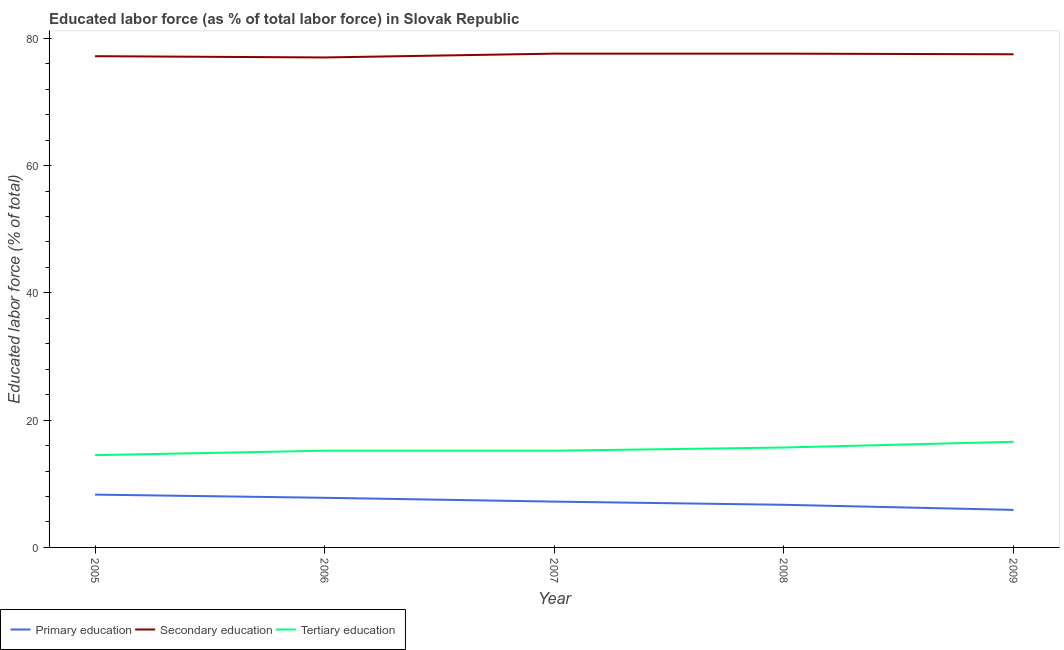How many different coloured lines are there?
Your response must be concise. 3. Is the number of lines equal to the number of legend labels?
Provide a succinct answer. Yes. What is the percentage of labor force who received primary education in 2008?
Ensure brevity in your answer.  6.7. Across all years, what is the maximum percentage of labor force who received secondary education?
Give a very brief answer. 77.6. Across all years, what is the minimum percentage of labor force who received secondary education?
Provide a short and direct response. 77. In which year was the percentage of labor force who received tertiary education maximum?
Give a very brief answer. 2009. In which year was the percentage of labor force who received tertiary education minimum?
Make the answer very short. 2005. What is the total percentage of labor force who received tertiary education in the graph?
Offer a terse response. 77.2. What is the difference between the percentage of labor force who received primary education in 2008 and that in 2009?
Offer a very short reply. 0.8. What is the difference between the percentage of labor force who received primary education in 2007 and the percentage of labor force who received secondary education in 2005?
Give a very brief answer. -70. What is the average percentage of labor force who received secondary education per year?
Ensure brevity in your answer.  77.38. In the year 2007, what is the difference between the percentage of labor force who received secondary education and percentage of labor force who received tertiary education?
Provide a succinct answer. 62.4. What is the ratio of the percentage of labor force who received tertiary education in 2008 to that in 2009?
Offer a terse response. 0.95. Is the percentage of labor force who received tertiary education in 2005 less than that in 2006?
Offer a very short reply. Yes. What is the difference between the highest and the second highest percentage of labor force who received primary education?
Provide a succinct answer. 0.5. What is the difference between the highest and the lowest percentage of labor force who received tertiary education?
Provide a short and direct response. 2.1. Is the sum of the percentage of labor force who received secondary education in 2005 and 2007 greater than the maximum percentage of labor force who received tertiary education across all years?
Your answer should be compact. Yes. Is it the case that in every year, the sum of the percentage of labor force who received primary education and percentage of labor force who received secondary education is greater than the percentage of labor force who received tertiary education?
Provide a short and direct response. Yes. How many lines are there?
Keep it short and to the point. 3. What is the difference between two consecutive major ticks on the Y-axis?
Your response must be concise. 20. Are the values on the major ticks of Y-axis written in scientific E-notation?
Your answer should be compact. No. Does the graph contain any zero values?
Your answer should be very brief. No. Does the graph contain grids?
Keep it short and to the point. No. Where does the legend appear in the graph?
Provide a short and direct response. Bottom left. What is the title of the graph?
Ensure brevity in your answer.  Educated labor force (as % of total labor force) in Slovak Republic. Does "Labor Tax" appear as one of the legend labels in the graph?
Provide a succinct answer. No. What is the label or title of the Y-axis?
Provide a short and direct response. Educated labor force (% of total). What is the Educated labor force (% of total) in Primary education in 2005?
Your answer should be very brief. 8.3. What is the Educated labor force (% of total) in Secondary education in 2005?
Your answer should be very brief. 77.2. What is the Educated labor force (% of total) of Tertiary education in 2005?
Provide a succinct answer. 14.5. What is the Educated labor force (% of total) of Primary education in 2006?
Your answer should be very brief. 7.8. What is the Educated labor force (% of total) in Tertiary education in 2006?
Make the answer very short. 15.2. What is the Educated labor force (% of total) of Primary education in 2007?
Your answer should be very brief. 7.2. What is the Educated labor force (% of total) in Secondary education in 2007?
Your response must be concise. 77.6. What is the Educated labor force (% of total) in Tertiary education in 2007?
Provide a short and direct response. 15.2. What is the Educated labor force (% of total) of Primary education in 2008?
Make the answer very short. 6.7. What is the Educated labor force (% of total) of Secondary education in 2008?
Provide a short and direct response. 77.6. What is the Educated labor force (% of total) in Tertiary education in 2008?
Provide a short and direct response. 15.7. What is the Educated labor force (% of total) in Primary education in 2009?
Your answer should be compact. 5.9. What is the Educated labor force (% of total) in Secondary education in 2009?
Offer a terse response. 77.5. What is the Educated labor force (% of total) of Tertiary education in 2009?
Your response must be concise. 16.6. Across all years, what is the maximum Educated labor force (% of total) of Primary education?
Provide a short and direct response. 8.3. Across all years, what is the maximum Educated labor force (% of total) in Secondary education?
Your answer should be compact. 77.6. Across all years, what is the maximum Educated labor force (% of total) in Tertiary education?
Offer a very short reply. 16.6. Across all years, what is the minimum Educated labor force (% of total) of Primary education?
Keep it short and to the point. 5.9. Across all years, what is the minimum Educated labor force (% of total) of Secondary education?
Your answer should be compact. 77. What is the total Educated labor force (% of total) in Primary education in the graph?
Provide a succinct answer. 35.9. What is the total Educated labor force (% of total) in Secondary education in the graph?
Keep it short and to the point. 386.9. What is the total Educated labor force (% of total) in Tertiary education in the graph?
Make the answer very short. 77.2. What is the difference between the Educated labor force (% of total) of Primary education in 2005 and that in 2006?
Provide a short and direct response. 0.5. What is the difference between the Educated labor force (% of total) of Secondary education in 2005 and that in 2006?
Ensure brevity in your answer.  0.2. What is the difference between the Educated labor force (% of total) in Tertiary education in 2005 and that in 2006?
Your answer should be compact. -0.7. What is the difference between the Educated labor force (% of total) of Tertiary education in 2005 and that in 2007?
Provide a succinct answer. -0.7. What is the difference between the Educated labor force (% of total) in Primary education in 2005 and that in 2008?
Offer a very short reply. 1.6. What is the difference between the Educated labor force (% of total) in Secondary education in 2005 and that in 2008?
Ensure brevity in your answer.  -0.4. What is the difference between the Educated labor force (% of total) of Secondary education in 2005 and that in 2009?
Offer a terse response. -0.3. What is the difference between the Educated labor force (% of total) of Secondary education in 2006 and that in 2007?
Your response must be concise. -0.6. What is the difference between the Educated labor force (% of total) in Tertiary education in 2006 and that in 2007?
Your answer should be compact. 0. What is the difference between the Educated labor force (% of total) of Primary education in 2006 and that in 2009?
Your answer should be compact. 1.9. What is the difference between the Educated labor force (% of total) in Secondary education in 2006 and that in 2009?
Provide a short and direct response. -0.5. What is the difference between the Educated labor force (% of total) of Tertiary education in 2006 and that in 2009?
Provide a short and direct response. -1.4. What is the difference between the Educated labor force (% of total) of Secondary education in 2007 and that in 2008?
Offer a very short reply. 0. What is the difference between the Educated labor force (% of total) in Tertiary education in 2007 and that in 2008?
Your answer should be compact. -0.5. What is the difference between the Educated labor force (% of total) of Primary education in 2008 and that in 2009?
Provide a short and direct response. 0.8. What is the difference between the Educated labor force (% of total) of Tertiary education in 2008 and that in 2009?
Offer a terse response. -0.9. What is the difference between the Educated labor force (% of total) in Primary education in 2005 and the Educated labor force (% of total) in Secondary education in 2006?
Offer a very short reply. -68.7. What is the difference between the Educated labor force (% of total) of Primary education in 2005 and the Educated labor force (% of total) of Secondary education in 2007?
Offer a very short reply. -69.3. What is the difference between the Educated labor force (% of total) of Secondary education in 2005 and the Educated labor force (% of total) of Tertiary education in 2007?
Your response must be concise. 62. What is the difference between the Educated labor force (% of total) of Primary education in 2005 and the Educated labor force (% of total) of Secondary education in 2008?
Offer a terse response. -69.3. What is the difference between the Educated labor force (% of total) of Secondary education in 2005 and the Educated labor force (% of total) of Tertiary education in 2008?
Your response must be concise. 61.5. What is the difference between the Educated labor force (% of total) in Primary education in 2005 and the Educated labor force (% of total) in Secondary education in 2009?
Make the answer very short. -69.2. What is the difference between the Educated labor force (% of total) of Secondary education in 2005 and the Educated labor force (% of total) of Tertiary education in 2009?
Make the answer very short. 60.6. What is the difference between the Educated labor force (% of total) of Primary education in 2006 and the Educated labor force (% of total) of Secondary education in 2007?
Ensure brevity in your answer.  -69.8. What is the difference between the Educated labor force (% of total) in Primary education in 2006 and the Educated labor force (% of total) in Tertiary education in 2007?
Your answer should be compact. -7.4. What is the difference between the Educated labor force (% of total) of Secondary education in 2006 and the Educated labor force (% of total) of Tertiary education in 2007?
Provide a short and direct response. 61.8. What is the difference between the Educated labor force (% of total) of Primary education in 2006 and the Educated labor force (% of total) of Secondary education in 2008?
Keep it short and to the point. -69.8. What is the difference between the Educated labor force (% of total) of Primary education in 2006 and the Educated labor force (% of total) of Tertiary education in 2008?
Ensure brevity in your answer.  -7.9. What is the difference between the Educated labor force (% of total) in Secondary education in 2006 and the Educated labor force (% of total) in Tertiary education in 2008?
Make the answer very short. 61.3. What is the difference between the Educated labor force (% of total) in Primary education in 2006 and the Educated labor force (% of total) in Secondary education in 2009?
Give a very brief answer. -69.7. What is the difference between the Educated labor force (% of total) in Secondary education in 2006 and the Educated labor force (% of total) in Tertiary education in 2009?
Keep it short and to the point. 60.4. What is the difference between the Educated labor force (% of total) in Primary education in 2007 and the Educated labor force (% of total) in Secondary education in 2008?
Your answer should be very brief. -70.4. What is the difference between the Educated labor force (% of total) of Primary education in 2007 and the Educated labor force (% of total) of Tertiary education in 2008?
Keep it short and to the point. -8.5. What is the difference between the Educated labor force (% of total) in Secondary education in 2007 and the Educated labor force (% of total) in Tertiary education in 2008?
Provide a short and direct response. 61.9. What is the difference between the Educated labor force (% of total) in Primary education in 2007 and the Educated labor force (% of total) in Secondary education in 2009?
Ensure brevity in your answer.  -70.3. What is the difference between the Educated labor force (% of total) of Secondary education in 2007 and the Educated labor force (% of total) of Tertiary education in 2009?
Provide a short and direct response. 61. What is the difference between the Educated labor force (% of total) in Primary education in 2008 and the Educated labor force (% of total) in Secondary education in 2009?
Your answer should be very brief. -70.8. What is the difference between the Educated labor force (% of total) in Secondary education in 2008 and the Educated labor force (% of total) in Tertiary education in 2009?
Keep it short and to the point. 61. What is the average Educated labor force (% of total) in Primary education per year?
Your answer should be compact. 7.18. What is the average Educated labor force (% of total) in Secondary education per year?
Provide a short and direct response. 77.38. What is the average Educated labor force (% of total) in Tertiary education per year?
Offer a terse response. 15.44. In the year 2005, what is the difference between the Educated labor force (% of total) of Primary education and Educated labor force (% of total) of Secondary education?
Your answer should be compact. -68.9. In the year 2005, what is the difference between the Educated labor force (% of total) in Primary education and Educated labor force (% of total) in Tertiary education?
Make the answer very short. -6.2. In the year 2005, what is the difference between the Educated labor force (% of total) of Secondary education and Educated labor force (% of total) of Tertiary education?
Your answer should be compact. 62.7. In the year 2006, what is the difference between the Educated labor force (% of total) in Primary education and Educated labor force (% of total) in Secondary education?
Offer a very short reply. -69.2. In the year 2006, what is the difference between the Educated labor force (% of total) in Primary education and Educated labor force (% of total) in Tertiary education?
Offer a terse response. -7.4. In the year 2006, what is the difference between the Educated labor force (% of total) in Secondary education and Educated labor force (% of total) in Tertiary education?
Your response must be concise. 61.8. In the year 2007, what is the difference between the Educated labor force (% of total) in Primary education and Educated labor force (% of total) in Secondary education?
Provide a succinct answer. -70.4. In the year 2007, what is the difference between the Educated labor force (% of total) of Primary education and Educated labor force (% of total) of Tertiary education?
Your response must be concise. -8. In the year 2007, what is the difference between the Educated labor force (% of total) in Secondary education and Educated labor force (% of total) in Tertiary education?
Give a very brief answer. 62.4. In the year 2008, what is the difference between the Educated labor force (% of total) of Primary education and Educated labor force (% of total) of Secondary education?
Give a very brief answer. -70.9. In the year 2008, what is the difference between the Educated labor force (% of total) of Primary education and Educated labor force (% of total) of Tertiary education?
Your answer should be compact. -9. In the year 2008, what is the difference between the Educated labor force (% of total) in Secondary education and Educated labor force (% of total) in Tertiary education?
Give a very brief answer. 61.9. In the year 2009, what is the difference between the Educated labor force (% of total) in Primary education and Educated labor force (% of total) in Secondary education?
Give a very brief answer. -71.6. In the year 2009, what is the difference between the Educated labor force (% of total) of Secondary education and Educated labor force (% of total) of Tertiary education?
Ensure brevity in your answer.  60.9. What is the ratio of the Educated labor force (% of total) in Primary education in 2005 to that in 2006?
Offer a very short reply. 1.06. What is the ratio of the Educated labor force (% of total) in Tertiary education in 2005 to that in 2006?
Offer a terse response. 0.95. What is the ratio of the Educated labor force (% of total) of Primary education in 2005 to that in 2007?
Your answer should be compact. 1.15. What is the ratio of the Educated labor force (% of total) in Tertiary education in 2005 to that in 2007?
Ensure brevity in your answer.  0.95. What is the ratio of the Educated labor force (% of total) in Primary education in 2005 to that in 2008?
Your answer should be compact. 1.24. What is the ratio of the Educated labor force (% of total) in Secondary education in 2005 to that in 2008?
Give a very brief answer. 0.99. What is the ratio of the Educated labor force (% of total) of Tertiary education in 2005 to that in 2008?
Make the answer very short. 0.92. What is the ratio of the Educated labor force (% of total) of Primary education in 2005 to that in 2009?
Provide a short and direct response. 1.41. What is the ratio of the Educated labor force (% of total) in Secondary education in 2005 to that in 2009?
Your answer should be compact. 1. What is the ratio of the Educated labor force (% of total) in Tertiary education in 2005 to that in 2009?
Ensure brevity in your answer.  0.87. What is the ratio of the Educated labor force (% of total) in Primary education in 2006 to that in 2007?
Your answer should be compact. 1.08. What is the ratio of the Educated labor force (% of total) in Primary education in 2006 to that in 2008?
Offer a terse response. 1.16. What is the ratio of the Educated labor force (% of total) in Secondary education in 2006 to that in 2008?
Your answer should be compact. 0.99. What is the ratio of the Educated labor force (% of total) of Tertiary education in 2006 to that in 2008?
Provide a short and direct response. 0.97. What is the ratio of the Educated labor force (% of total) in Primary education in 2006 to that in 2009?
Your response must be concise. 1.32. What is the ratio of the Educated labor force (% of total) of Tertiary education in 2006 to that in 2009?
Offer a terse response. 0.92. What is the ratio of the Educated labor force (% of total) in Primary education in 2007 to that in 2008?
Offer a very short reply. 1.07. What is the ratio of the Educated labor force (% of total) in Tertiary education in 2007 to that in 2008?
Offer a very short reply. 0.97. What is the ratio of the Educated labor force (% of total) in Primary education in 2007 to that in 2009?
Keep it short and to the point. 1.22. What is the ratio of the Educated labor force (% of total) of Tertiary education in 2007 to that in 2009?
Offer a very short reply. 0.92. What is the ratio of the Educated labor force (% of total) of Primary education in 2008 to that in 2009?
Ensure brevity in your answer.  1.14. What is the ratio of the Educated labor force (% of total) in Secondary education in 2008 to that in 2009?
Your answer should be very brief. 1. What is the ratio of the Educated labor force (% of total) in Tertiary education in 2008 to that in 2009?
Your answer should be compact. 0.95. What is the difference between the highest and the second highest Educated labor force (% of total) of Secondary education?
Offer a very short reply. 0. What is the difference between the highest and the lowest Educated labor force (% of total) in Primary education?
Ensure brevity in your answer.  2.4. What is the difference between the highest and the lowest Educated labor force (% of total) of Tertiary education?
Make the answer very short. 2.1. 